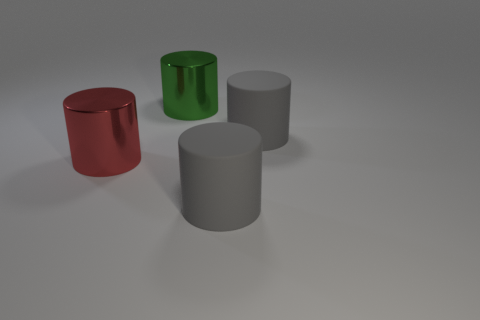Add 2 green metallic cylinders. How many objects exist? 6 Subtract 0 purple cylinders. How many objects are left? 4 Subtract all green cylinders. Subtract all tiny cyan matte cubes. How many objects are left? 3 Add 4 large shiny things. How many large shiny things are left? 6 Add 2 small red matte cylinders. How many small red matte cylinders exist? 2 